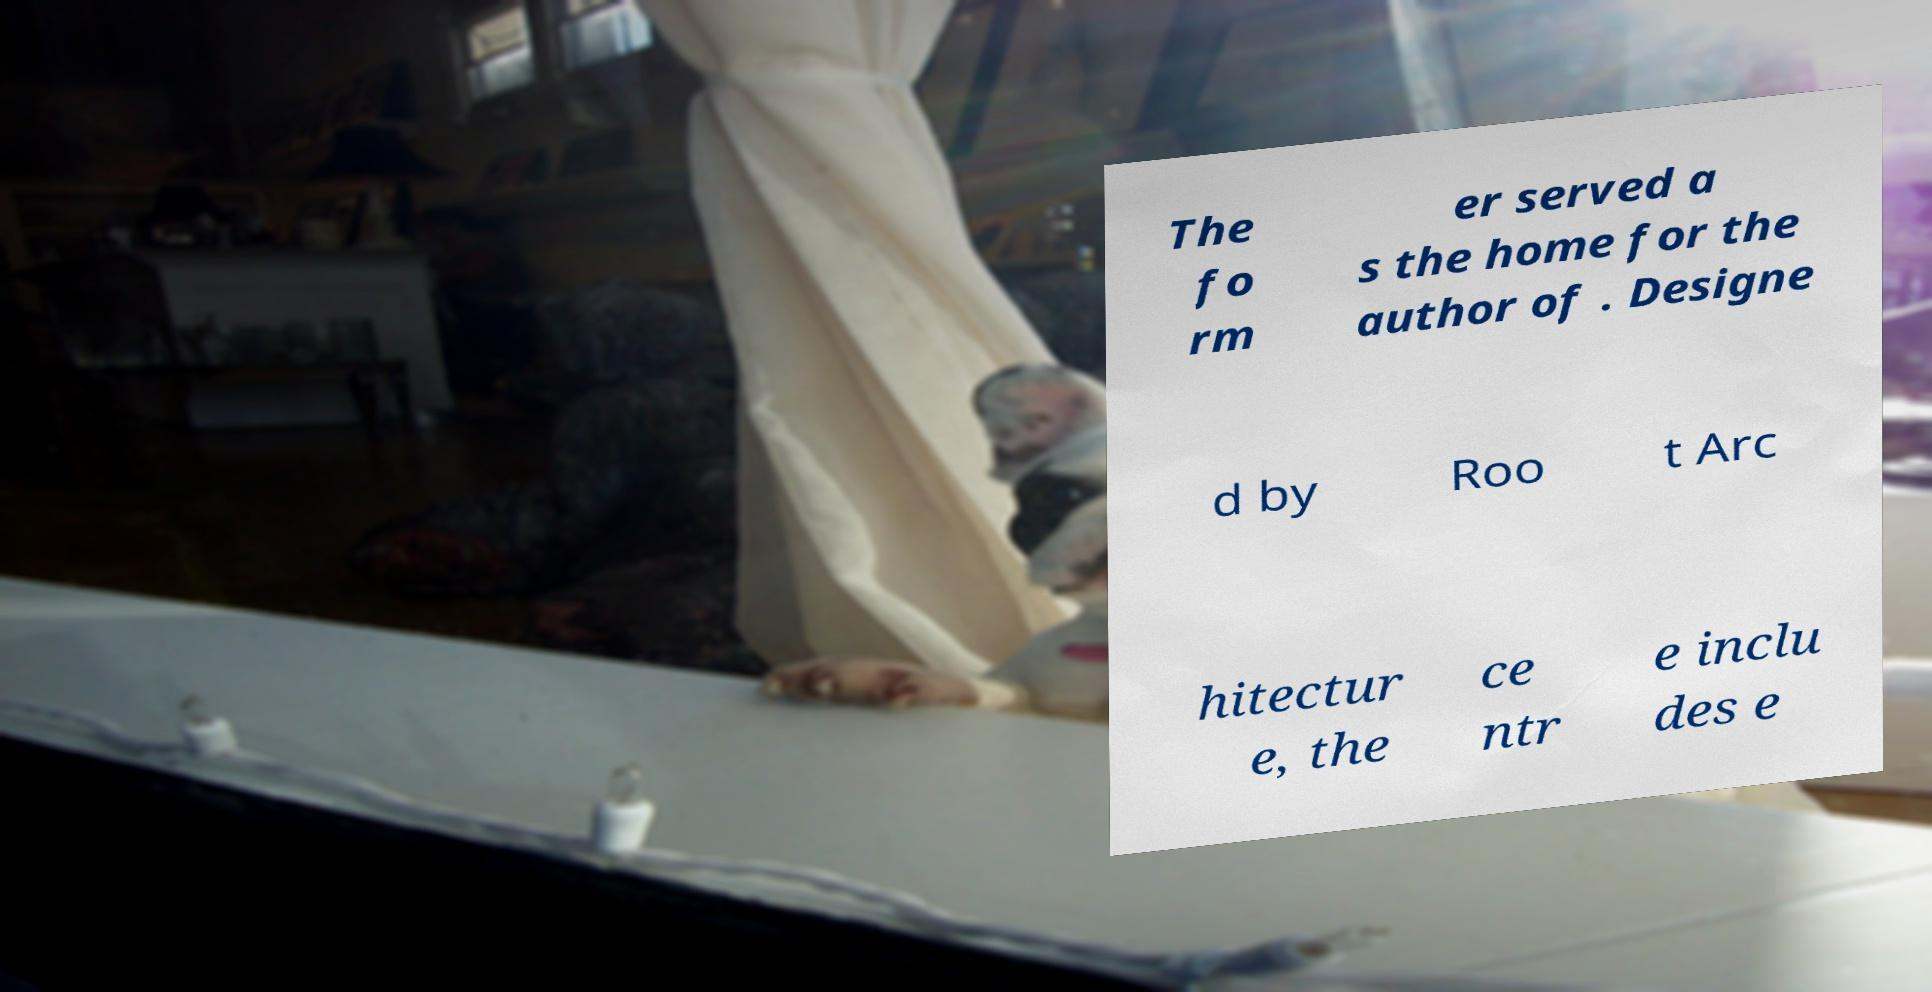Can you read and provide the text displayed in the image?This photo seems to have some interesting text. Can you extract and type it out for me? The fo rm er served a s the home for the author of . Designe d by Roo t Arc hitectur e, the ce ntr e inclu des e 